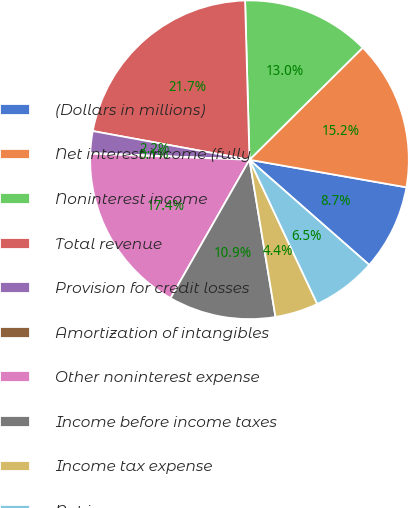Convert chart. <chart><loc_0><loc_0><loc_500><loc_500><pie_chart><fcel>(Dollars in millions)<fcel>Net interest income (fully<fcel>Noninterest income<fcel>Total revenue<fcel>Provision for credit losses<fcel>Amortization of intangibles<fcel>Other noninterest expense<fcel>Income before income taxes<fcel>Income tax expense<fcel>Net income<nl><fcel>8.7%<fcel>15.18%<fcel>13.02%<fcel>21.67%<fcel>2.22%<fcel>0.06%<fcel>17.35%<fcel>10.86%<fcel>4.38%<fcel>6.54%<nl></chart> 